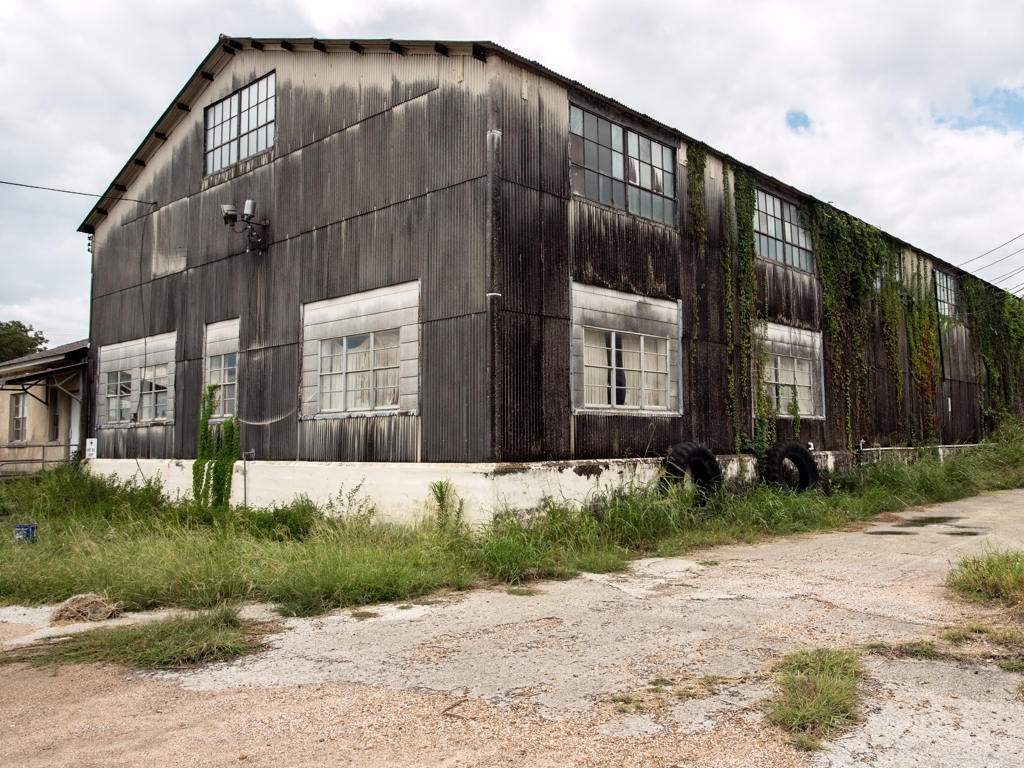What can you tell me about the plants growing on the building? The image shows a building partially covered with climbing plants, likely a species of ivy or vine. These plants are often found in areas where they are left to grow undisturbed, such as on the walls of abandoned or under-maintained structures. They add a touch of greenery and can sometimes cause damage to the building's structure over time by their growth and root systems. 